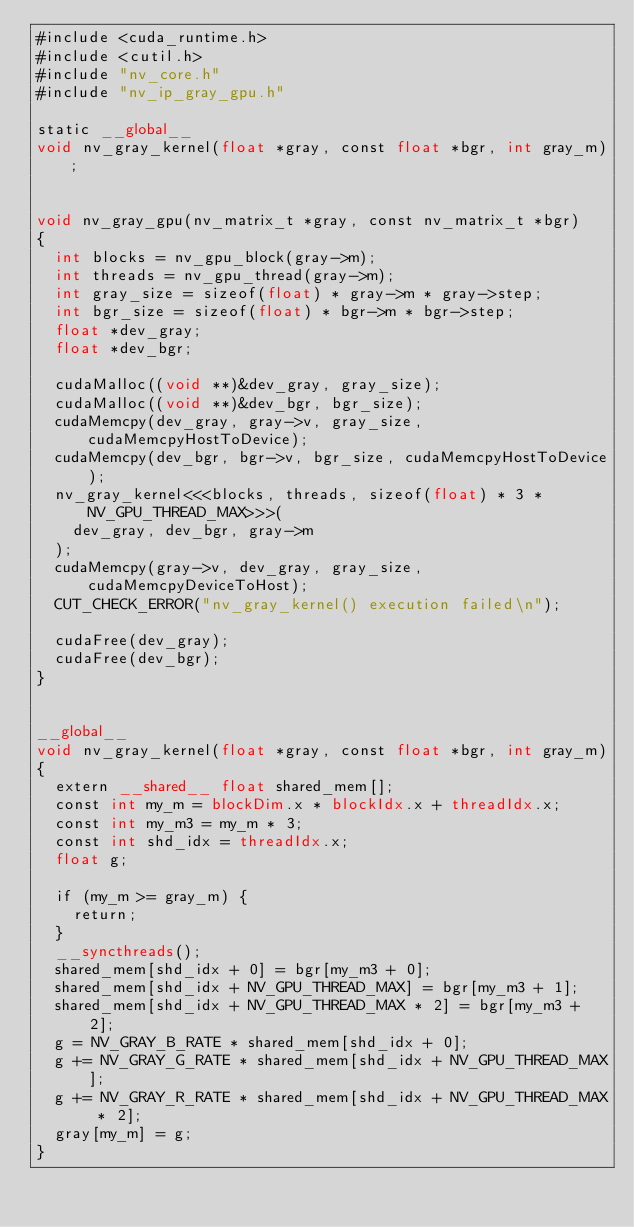<code> <loc_0><loc_0><loc_500><loc_500><_Cuda_>#include <cuda_runtime.h>
#include <cutil.h>
#include "nv_core.h"
#include "nv_ip_gray_gpu.h"

static __global__ 
void nv_gray_kernel(float *gray, const float *bgr, int gray_m);


void nv_gray_gpu(nv_matrix_t *gray, const nv_matrix_t *bgr)
{
	int blocks = nv_gpu_block(gray->m);
	int threads = nv_gpu_thread(gray->m);
	int gray_size = sizeof(float) * gray->m * gray->step;
	int bgr_size = sizeof(float) * bgr->m * bgr->step;
	float *dev_gray;
	float *dev_bgr;

	cudaMalloc((void **)&dev_gray, gray_size);
	cudaMalloc((void **)&dev_bgr, bgr_size);
	cudaMemcpy(dev_gray, gray->v, gray_size, cudaMemcpyHostToDevice);
	cudaMemcpy(dev_bgr, bgr->v, bgr_size, cudaMemcpyHostToDevice);
	nv_gray_kernel<<<blocks, threads, sizeof(float) * 3 * NV_GPU_THREAD_MAX>>>(
		dev_gray, dev_bgr, gray->m
	);
	cudaMemcpy(gray->v, dev_gray, gray_size, cudaMemcpyDeviceToHost);
	CUT_CHECK_ERROR("nv_gray_kernel() execution failed\n");

	cudaFree(dev_gray);
	cudaFree(dev_bgr);
}


__global__ 
void nv_gray_kernel(float *gray, const float *bgr, int gray_m)
{
	extern __shared__ float shared_mem[];
	const int my_m = blockDim.x * blockIdx.x + threadIdx.x;
	const int my_m3 = my_m * 3;
	const int shd_idx = threadIdx.x;
	float g;

	if (my_m >= gray_m) {
		return;
	}
	__syncthreads();
	shared_mem[shd_idx + 0] = bgr[my_m3 + 0];
	shared_mem[shd_idx + NV_GPU_THREAD_MAX] = bgr[my_m3 + 1];
	shared_mem[shd_idx + NV_GPU_THREAD_MAX * 2] = bgr[my_m3 + 2];
	g = NV_GRAY_B_RATE * shared_mem[shd_idx + 0];
	g += NV_GRAY_G_RATE * shared_mem[shd_idx + NV_GPU_THREAD_MAX];
	g += NV_GRAY_R_RATE * shared_mem[shd_idx + NV_GPU_THREAD_MAX * 2];
	gray[my_m] = g;
}
</code> 